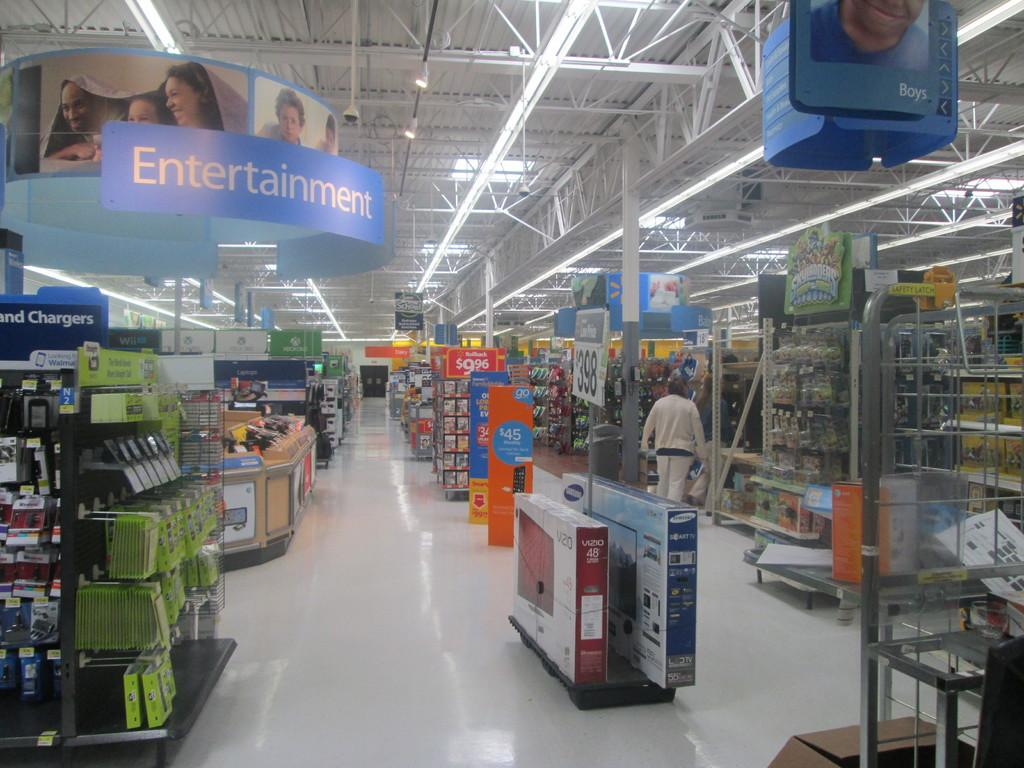<image>
Relay a brief, clear account of the picture shown. a Walmart store with an Entertainment sign hanging from the ceiling 